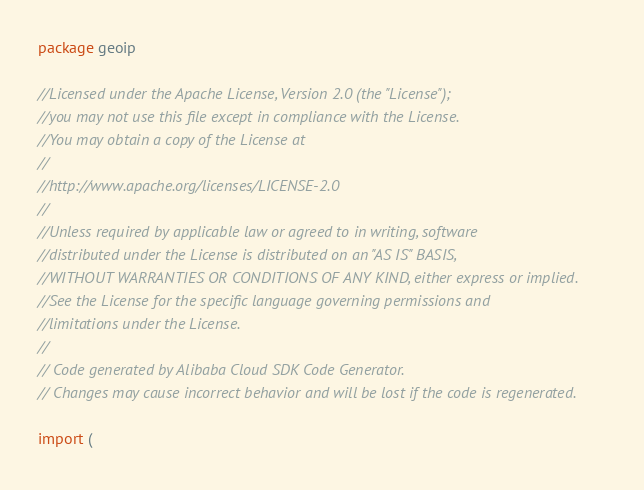Convert code to text. <code><loc_0><loc_0><loc_500><loc_500><_Go_>package geoip

//Licensed under the Apache License, Version 2.0 (the "License");
//you may not use this file except in compliance with the License.
//You may obtain a copy of the License at
//
//http://www.apache.org/licenses/LICENSE-2.0
//
//Unless required by applicable law or agreed to in writing, software
//distributed under the License is distributed on an "AS IS" BASIS,
//WITHOUT WARRANTIES OR CONDITIONS OF ANY KIND, either express or implied.
//See the License for the specific language governing permissions and
//limitations under the License.
//
// Code generated by Alibaba Cloud SDK Code Generator.
// Changes may cause incorrect behavior and will be lost if the code is regenerated.

import (</code> 